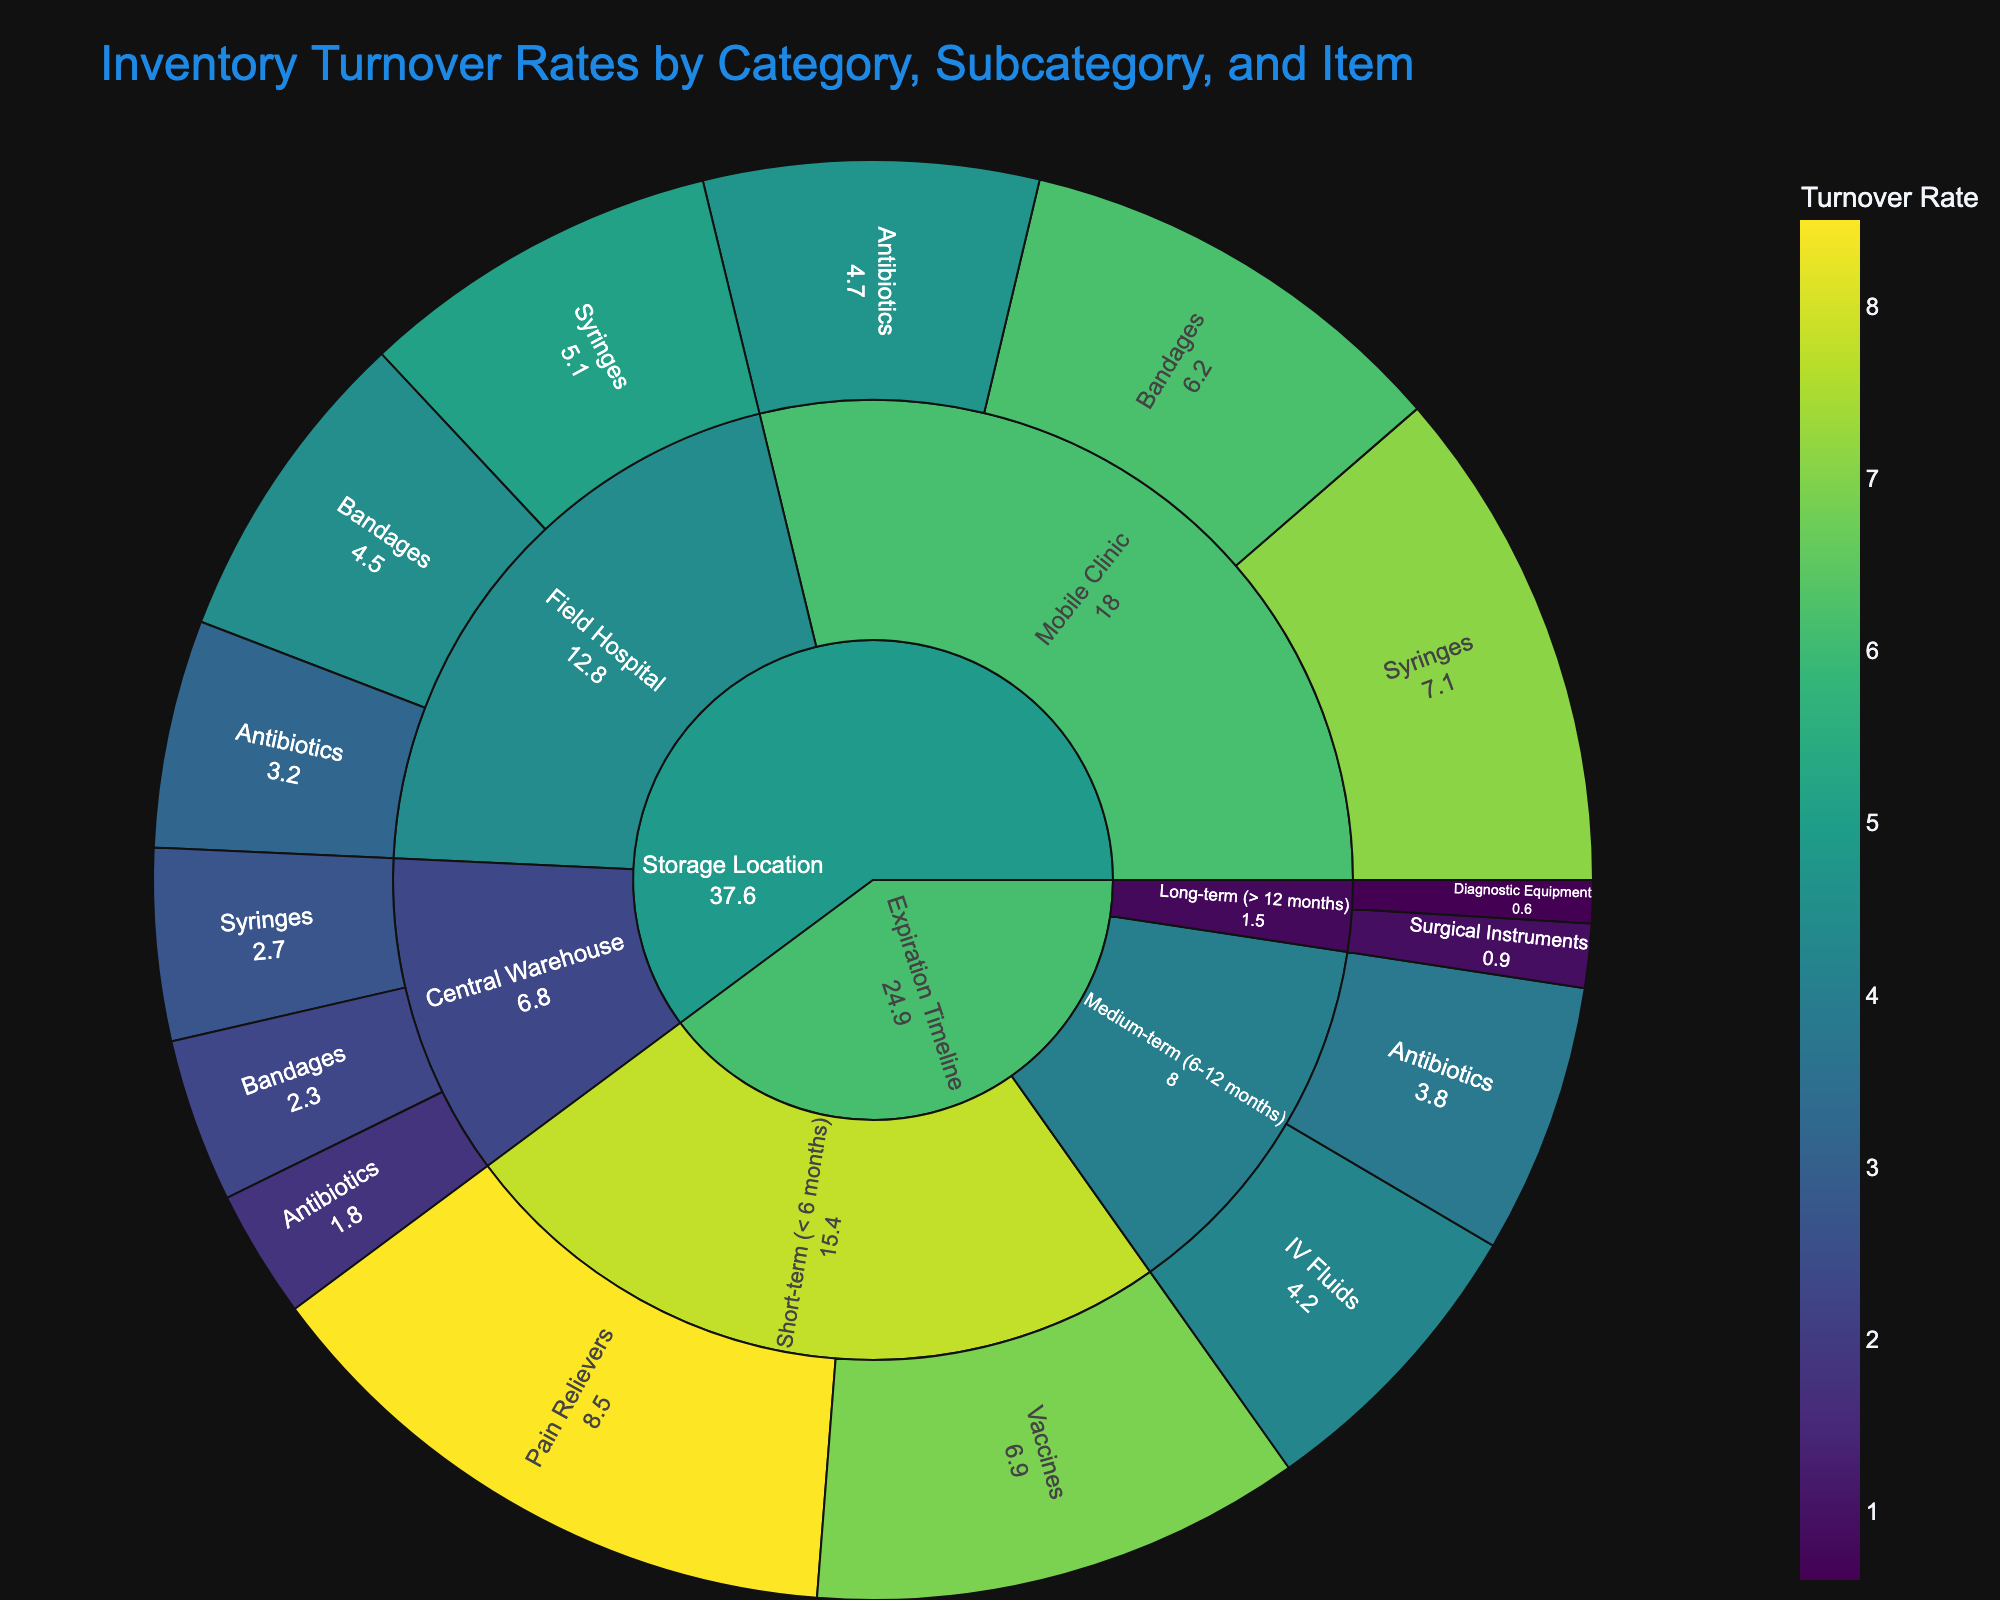What is the title of the Sunburst Plot? The title can be found at the top of the plot.
Answer: Inventory Turnover Rates by Category, Subcategory, and Item Which item has the highest turnover rate? Look for the item with the largest value in the plot.
Answer: Pain Relievers What is the average turnover rate for items stored in the Central Warehouse? Identify the turnover rates for all items under the Central Warehouse, then calculate their average. (1.8 + 2.3 + 2.7) / 3 = 2.27
Answer: 2.27 What are the categories in the plot? Examine the outermost layer of the Sunburst Plot to see the main segments.
Answer: Storage Location, Expiration Timeline Compare the turnover rate of Antibiotics in Field Hospital and Mobile Clinic. Which is higher? Find the sections for Antibiotics under Field Hospital and Mobile Clinic, then compare their values (3.2 vs 4.7).
Answer: Mobile Clinic What storage location has the highest overall turnover rate for all its items? Sum the turnover rates of all items within each storage location, then compare.
Answer: Mobile Clinic Which item in the Long-term category has the lowest turnover rate? Look within the Long-term (> 12 months) segment for the smallest turnover rate.
Answer: Diagnostic Equipment What is the combined turnover rate for all items with a short-term expiration timeline? Add the turnover rates for short-term items: 8.5 + 6.9 = 15.4
Answer: 15.4 In terms of turnover rates, which has a greater variance: items categorized by Storage Location or by Expiration Timeline? Compare the range of turnover rates within each main category (1.8 to 7.1 for Storage Location, 0.6 to 8.5 for Expiration Timeline).
Answer: Expiration Timeline How does the turnover rate for IV Fluids compare to the average turnover rate of items with a medium-term expiration timeline? Calculate the average of medium-term items' turnover rates (3.8 + 4.2) / 2 = 4.0, then compare IV Fluids' rate (4.2) to this average.
Answer: Higher 